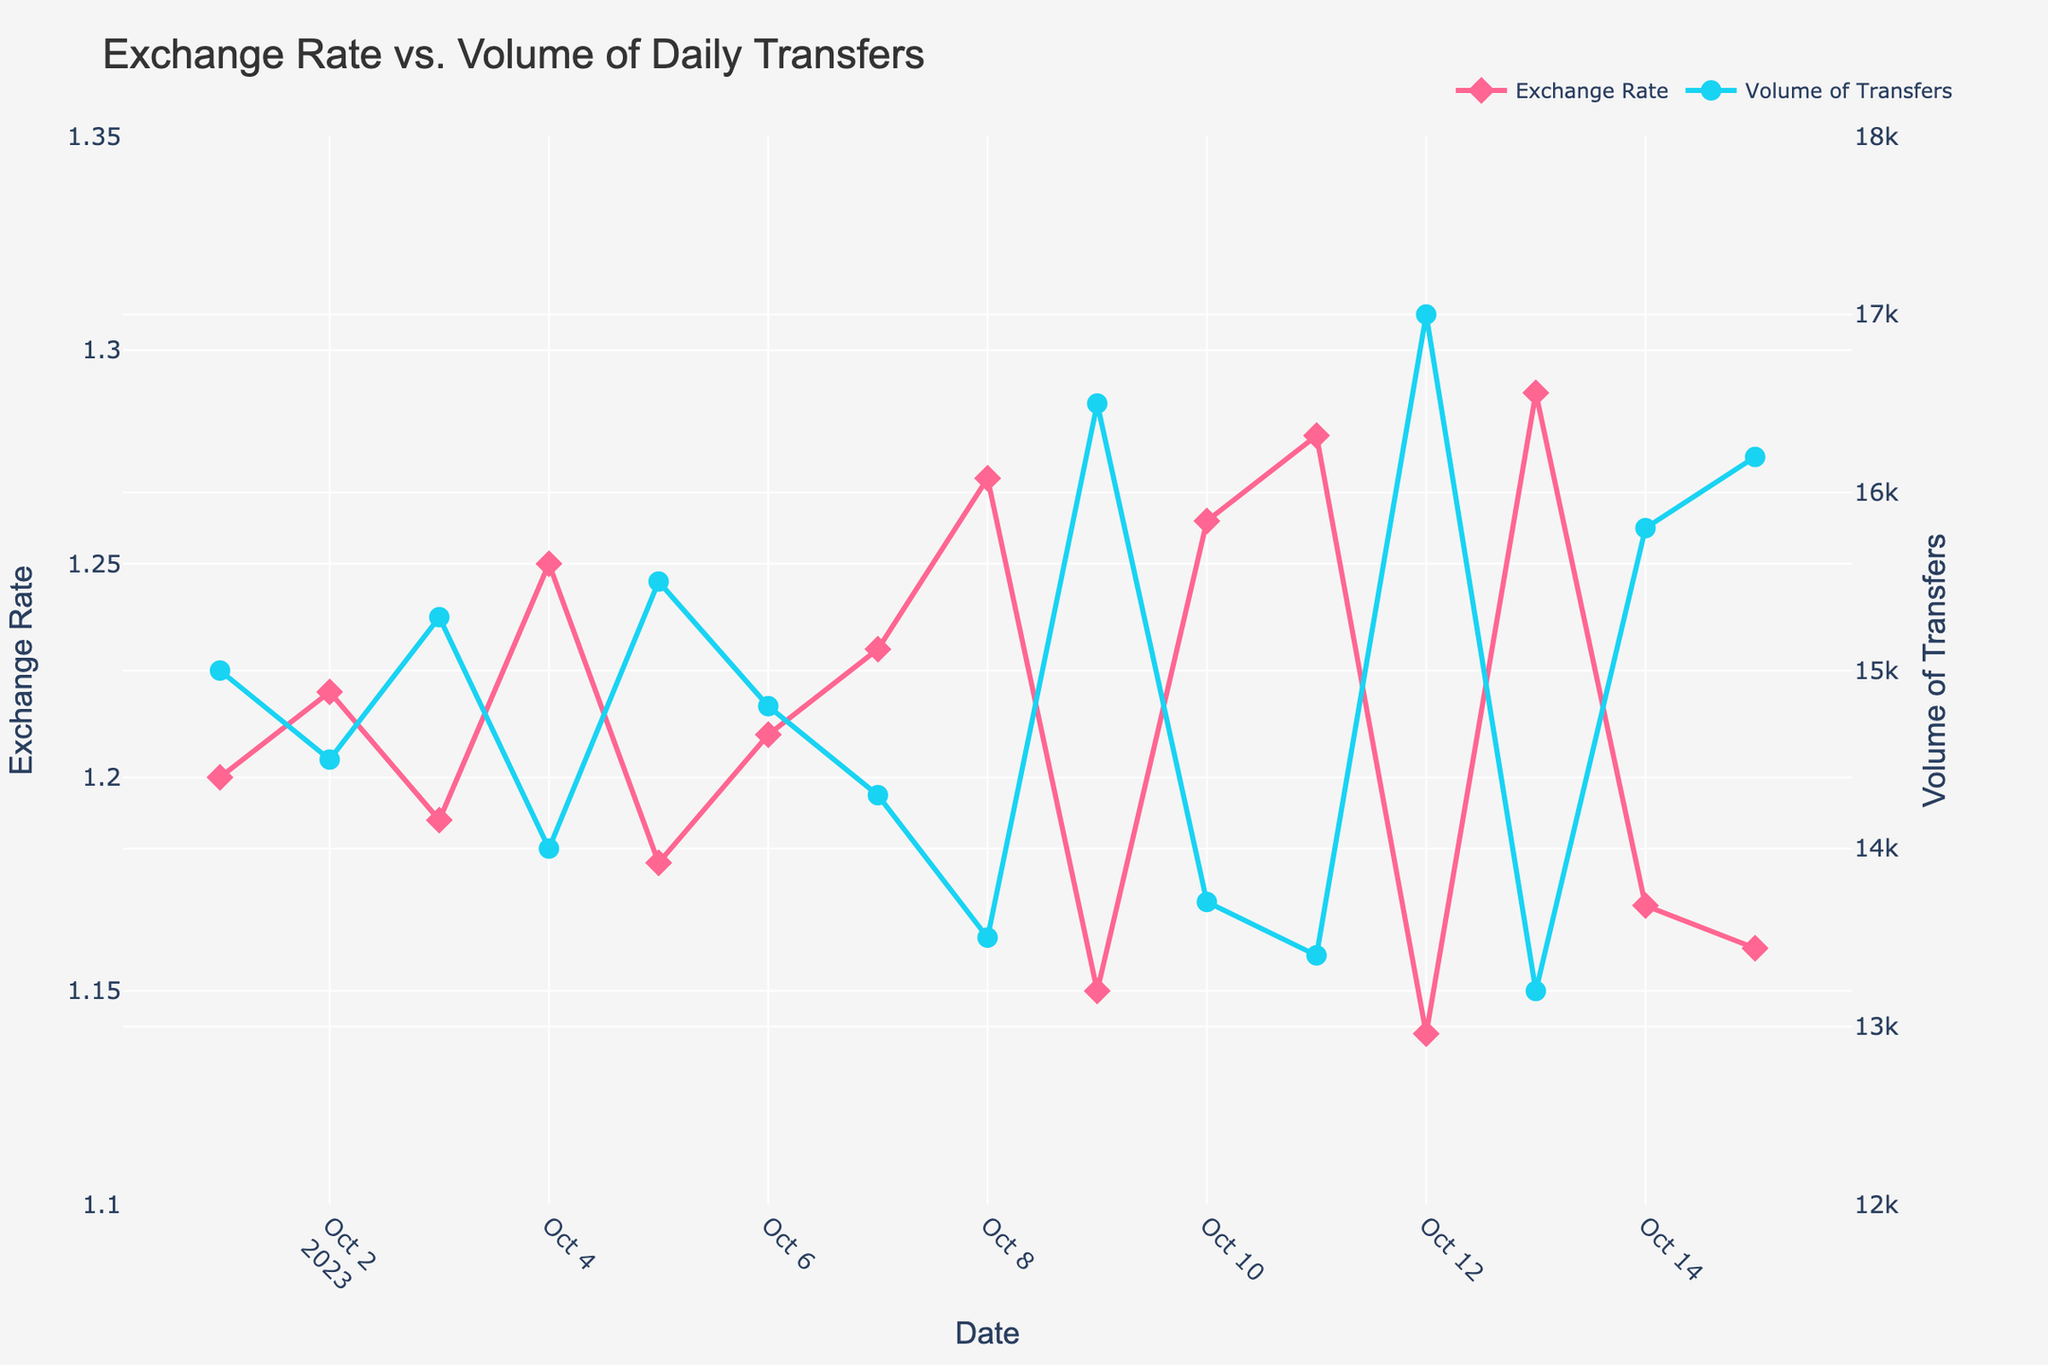How many data points are there for both Exchange Rate and Volume of Transfers? Count the number of points (markers) plotted. There should be a point for every date from October 1 to October 15.
Answer: 15 What is the title of the plot? The title of the plot is written at the top center of the figure.
Answer: Exchange Rate vs. Volume of Daily Transfers Which variable is displayed on the primary y-axis? The primary y-axis is on the left side of the plot, and the label of the y-axis will tell which variable it is representing.
Answer: Exchange Rate On which date did the Exchange Rate reach its highest value? Look at the plot and find the point where the Exchange Rate has its maximum value, then check the corresponding date on the x-axis.
Answer: 2023-10-13 What colors represent Exchange Rate and Volume of Transfers, respectively? Identify the color of the lines and markers in the legend or by visual inspection.
Answer: Pink and Blue What is the average Volume of Transfers over the observed period? Add up all the Volume of Transfers values and divide by the number of data points (15). \[ \text{(15000 + 14500 + 15300 + 14000 + 15500 + 14800 + 14300 + 13500 + 16500 + 13700 + 13400 + 17000 + 13200 + 15800 + 16200)} / 15 \]
Answer: 14980 Between which two dates did the Exchange Rate experience the largest increase? Calculate the difference in Exchange Rates between consecutive dates and identify the maximum increase. The dates corresponding to this increase will be the answer.
Answer: 2023-10-11 to 2023-10-12 How does the Volume of Transfers correlate with Exchange Rate? Observe how the Volume of Transfers changes relative to changes in Exchange Rate across the plotted dates and state the nature of their relationship (positive, negative, or no clear correlation).
Answer: Inversely Which date shows the lowest Volume of Transfers, and what is that volume? Identify the point with the minimum value on the Volume of Transfers line and note its corresponding date and value.
Answer: 2023-10-13 with 13200 What is the range of the Exchange Rate values observed in the plot? Identify the minimum and maximum values of the Exchange Rate from the plot and calculate the difference.
Answer: 1.14 to 1.29 